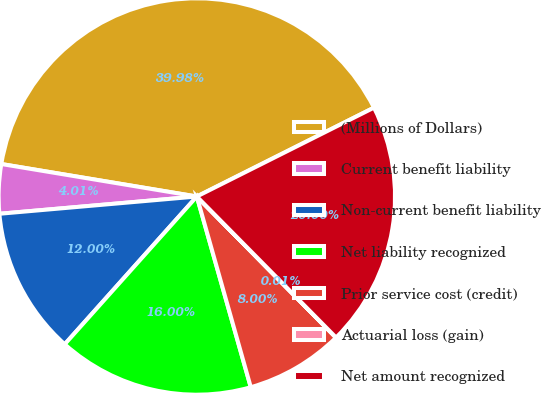Convert chart to OTSL. <chart><loc_0><loc_0><loc_500><loc_500><pie_chart><fcel>(Millions of Dollars)<fcel>Current benefit liability<fcel>Non-current benefit liability<fcel>Net liability recognized<fcel>Prior service cost (credit)<fcel>Actuarial loss (gain)<fcel>Net amount recognized<nl><fcel>39.98%<fcel>4.01%<fcel>12.0%<fcel>16.0%<fcel>8.0%<fcel>0.01%<fcel>20.0%<nl></chart> 